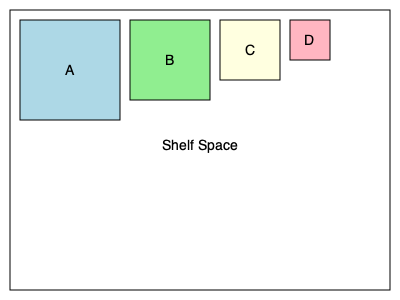You need to arrange storage containers for various forest maintenance tools on a shelf. Given containers A (10x10), B (8x8), C (6x6), and D (4x4), what is the maximum number of complete sets (one of each container) that can fit on a shelf measuring 30x10 units? To solve this problem, we need to follow these steps:

1. Calculate the area of each container:
   A: $10 \times 10 = 100$ square units
   B: $8 \times 8 = 64$ square units
   C: $6 \times 6 = 36$ square units
   D: $4 \times 4 = 16$ square units

2. Calculate the total area of one complete set:
   $100 + 64 + 36 + 16 = 216$ square units

3. Calculate the total area of the shelf:
   $30 \times 10 = 300$ square units

4. Divide the shelf area by the area of one complete set:
   $\frac{300}{216} \approx 1.389$

5. Since we can only use complete sets, we round down to the nearest whole number.

Therefore, the maximum number of complete sets that can fit on the shelf is 1.
Answer: 1 set 